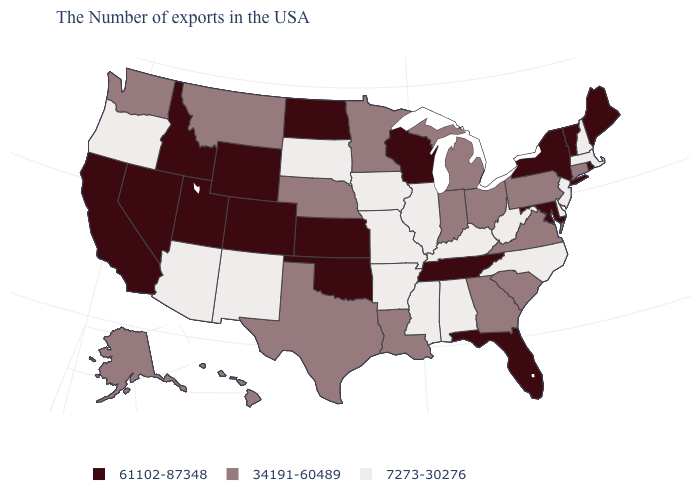Which states have the lowest value in the West?
Give a very brief answer. New Mexico, Arizona, Oregon. What is the value of Connecticut?
Write a very short answer. 34191-60489. Is the legend a continuous bar?
Keep it brief. No. Name the states that have a value in the range 61102-87348?
Short answer required. Maine, Rhode Island, Vermont, New York, Maryland, Florida, Tennessee, Wisconsin, Kansas, Oklahoma, North Dakota, Wyoming, Colorado, Utah, Idaho, Nevada, California. Name the states that have a value in the range 61102-87348?
Concise answer only. Maine, Rhode Island, Vermont, New York, Maryland, Florida, Tennessee, Wisconsin, Kansas, Oklahoma, North Dakota, Wyoming, Colorado, Utah, Idaho, Nevada, California. Name the states that have a value in the range 61102-87348?
Short answer required. Maine, Rhode Island, Vermont, New York, Maryland, Florida, Tennessee, Wisconsin, Kansas, Oklahoma, North Dakota, Wyoming, Colorado, Utah, Idaho, Nevada, California. What is the value of Idaho?
Give a very brief answer. 61102-87348. Name the states that have a value in the range 7273-30276?
Write a very short answer. Massachusetts, New Hampshire, New Jersey, Delaware, North Carolina, West Virginia, Kentucky, Alabama, Illinois, Mississippi, Missouri, Arkansas, Iowa, South Dakota, New Mexico, Arizona, Oregon. Among the states that border West Virginia , does Kentucky have the lowest value?
Answer briefly. Yes. Name the states that have a value in the range 7273-30276?
Write a very short answer. Massachusetts, New Hampshire, New Jersey, Delaware, North Carolina, West Virginia, Kentucky, Alabama, Illinois, Mississippi, Missouri, Arkansas, Iowa, South Dakota, New Mexico, Arizona, Oregon. What is the lowest value in states that border Minnesota?
Keep it brief. 7273-30276. Name the states that have a value in the range 34191-60489?
Write a very short answer. Connecticut, Pennsylvania, Virginia, South Carolina, Ohio, Georgia, Michigan, Indiana, Louisiana, Minnesota, Nebraska, Texas, Montana, Washington, Alaska, Hawaii. Does the first symbol in the legend represent the smallest category?
Keep it brief. No. Among the states that border Rhode Island , which have the highest value?
Keep it brief. Connecticut. Among the states that border Oklahoma , does New Mexico have the highest value?
Be succinct. No. 